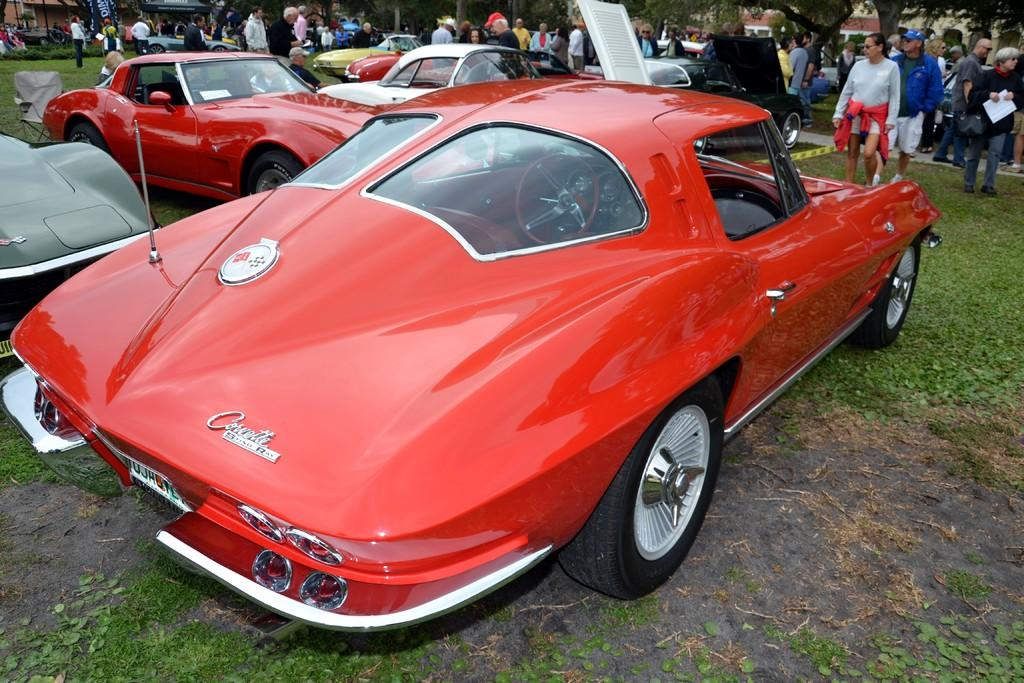What types of objects can be seen in the image? There are many vehicles, trees, buildings, and people in the image. What is the landscape like in the image? The image features a grassy land. How many different elements can be identified in the image? There are at least five different elements: vehicles, trees, buildings, grassy land, and people. What type of drink is being served in the image? There is no drink present in the image; it features vehicles, trees, buildings, grassy land, and people. How many cherries are on top of the buildings in the image? There are no cherries present in the image; it features vehicles, trees, buildings, grassy land, and people. 